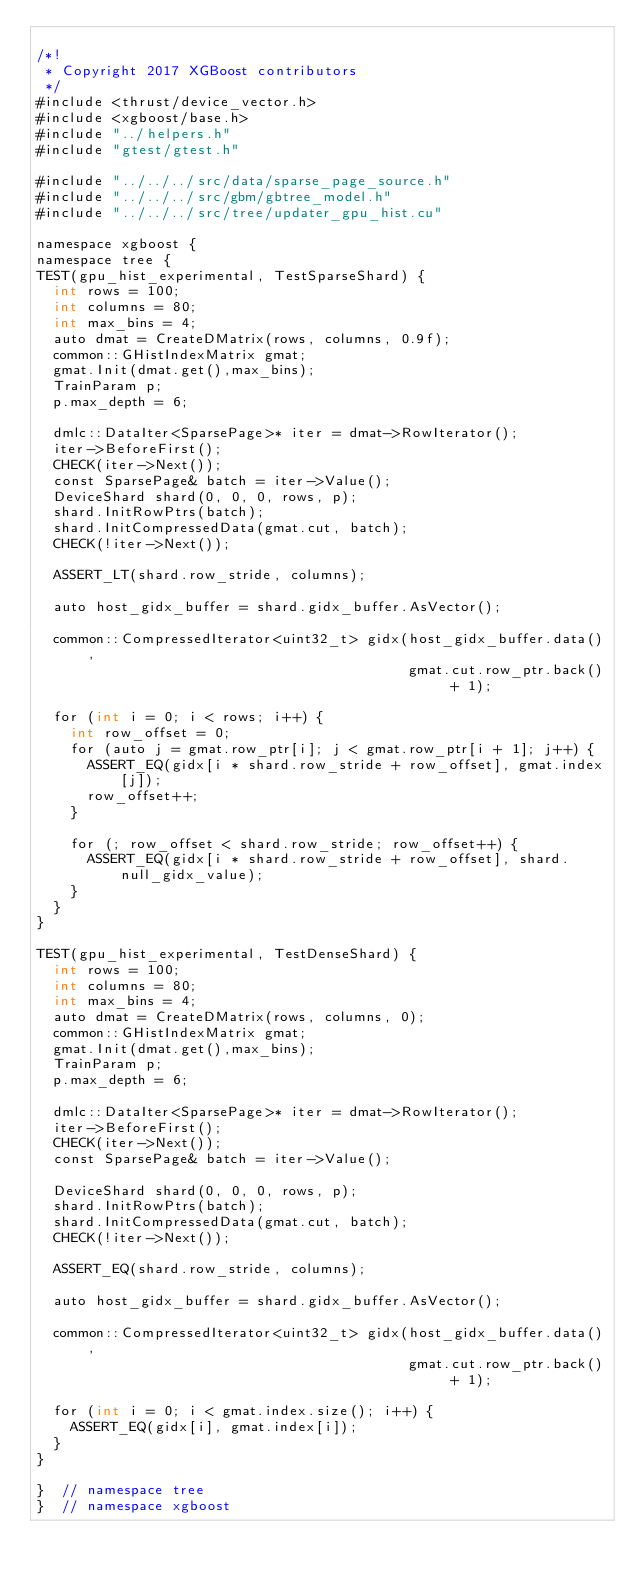Convert code to text. <code><loc_0><loc_0><loc_500><loc_500><_Cuda_>
/*!
 * Copyright 2017 XGBoost contributors
 */
#include <thrust/device_vector.h>
#include <xgboost/base.h>
#include "../helpers.h"
#include "gtest/gtest.h"

#include "../../../src/data/sparse_page_source.h"
#include "../../../src/gbm/gbtree_model.h"
#include "../../../src/tree/updater_gpu_hist.cu"

namespace xgboost {
namespace tree {
TEST(gpu_hist_experimental, TestSparseShard) {
  int rows = 100;
  int columns = 80;
  int max_bins = 4;
  auto dmat = CreateDMatrix(rows, columns, 0.9f);
  common::GHistIndexMatrix gmat;
  gmat.Init(dmat.get(),max_bins);
  TrainParam p;
  p.max_depth = 6;

  dmlc::DataIter<SparsePage>* iter = dmat->RowIterator();
  iter->BeforeFirst();
  CHECK(iter->Next());
  const SparsePage& batch = iter->Value();
  DeviceShard shard(0, 0, 0, rows, p);
  shard.InitRowPtrs(batch);
  shard.InitCompressedData(gmat.cut, batch);
  CHECK(!iter->Next());

  ASSERT_LT(shard.row_stride, columns);

  auto host_gidx_buffer = shard.gidx_buffer.AsVector();

  common::CompressedIterator<uint32_t> gidx(host_gidx_buffer.data(),
                                            gmat.cut.row_ptr.back() + 1);

  for (int i = 0; i < rows; i++) {
    int row_offset = 0;
    for (auto j = gmat.row_ptr[i]; j < gmat.row_ptr[i + 1]; j++) {
      ASSERT_EQ(gidx[i * shard.row_stride + row_offset], gmat.index[j]);
      row_offset++;
    }

    for (; row_offset < shard.row_stride; row_offset++) {
      ASSERT_EQ(gidx[i * shard.row_stride + row_offset], shard.null_gidx_value);
    }
  }
}

TEST(gpu_hist_experimental, TestDenseShard) {
  int rows = 100;
  int columns = 80;
  int max_bins = 4;
  auto dmat = CreateDMatrix(rows, columns, 0);
  common::GHistIndexMatrix gmat;
  gmat.Init(dmat.get(),max_bins);
  TrainParam p;
  p.max_depth = 6;

  dmlc::DataIter<SparsePage>* iter = dmat->RowIterator();
  iter->BeforeFirst();
  CHECK(iter->Next());
  const SparsePage& batch = iter->Value();

  DeviceShard shard(0, 0, 0, rows, p);
  shard.InitRowPtrs(batch);
  shard.InitCompressedData(gmat.cut, batch);
  CHECK(!iter->Next());

  ASSERT_EQ(shard.row_stride, columns);

  auto host_gidx_buffer = shard.gidx_buffer.AsVector();

  common::CompressedIterator<uint32_t> gidx(host_gidx_buffer.data(),
                                            gmat.cut.row_ptr.back() + 1);

  for (int i = 0; i < gmat.index.size(); i++) {
    ASSERT_EQ(gidx[i], gmat.index[i]);
  }
}

}  // namespace tree
}  // namespace xgboost
</code> 